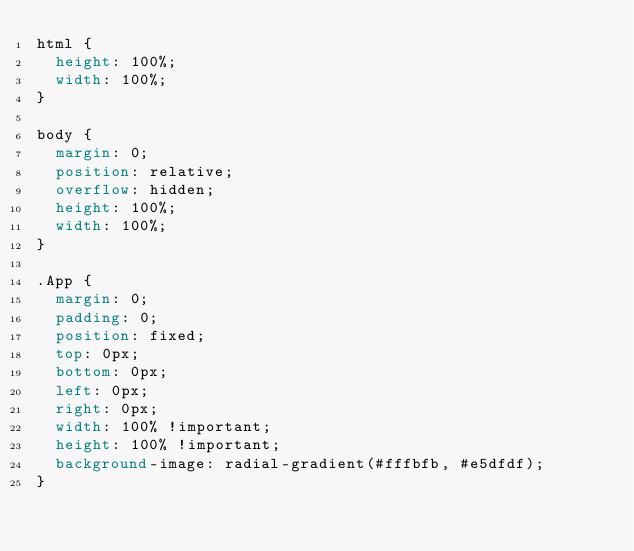<code> <loc_0><loc_0><loc_500><loc_500><_CSS_>html {
  height: 100%;
  width: 100%;
}

body {
  margin: 0;
  position: relative;
  overflow: hidden;
  height: 100%;
  width: 100%;
}

.App {
  margin: 0;
  padding: 0;
  position: fixed;
  top: 0px;
  bottom: 0px;
  left: 0px;
  right: 0px;
  width: 100% !important;
  height: 100% !important;
  background-image: radial-gradient(#fffbfb, #e5dfdf);
}
</code> 